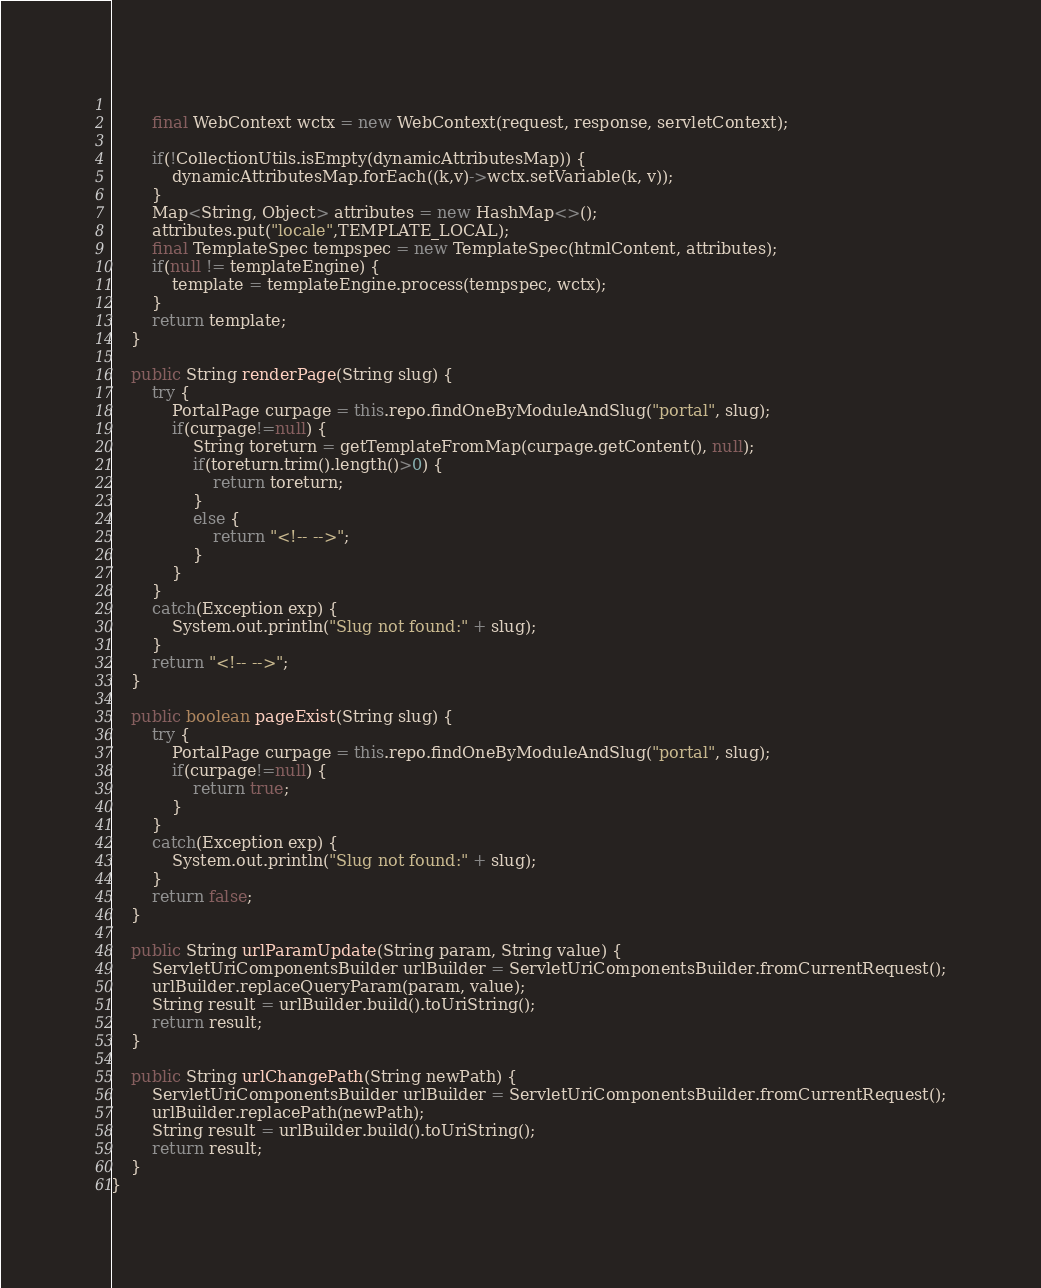<code> <loc_0><loc_0><loc_500><loc_500><_Java_>		
		final WebContext wctx = new WebContext(request, response, servletContext);
		
		if(!CollectionUtils.isEmpty(dynamicAttributesMap)) {
			dynamicAttributesMap.forEach((k,v)->wctx.setVariable(k, v));
		}
		Map<String, Object> attributes = new HashMap<>();
		attributes.put("locale",TEMPLATE_LOCAL);
		final TemplateSpec tempspec = new TemplateSpec(htmlContent, attributes);
		if(null != templateEngine) {
			template = templateEngine.process(tempspec, wctx);
		}
		return template;
	}
	
	public String renderPage(String slug) {		
		try {
			PortalPage curpage = this.repo.findOneByModuleAndSlug("portal", slug);
			if(curpage!=null) {
				String toreturn = getTemplateFromMap(curpage.getContent(), null);
				if(toreturn.trim().length()>0) {
					return toreturn;
				}
				else {					
					return "<!-- -->";
				}
			}
		}
		catch(Exception exp) {
			System.out.println("Slug not found:" + slug);
		}		
		return "<!-- -->";
	}
	
	public boolean pageExist(String slug) {
		try {
			PortalPage curpage = this.repo.findOneByModuleAndSlug("portal", slug);
			if(curpage!=null) {
				return true;
			}
		}
		catch(Exception exp) {
			System.out.println("Slug not found:" + slug);
		}
		return false;
	}
	
	public String urlParamUpdate(String param, String value) {		
		ServletUriComponentsBuilder urlBuilder = ServletUriComponentsBuilder.fromCurrentRequest();
		urlBuilder.replaceQueryParam(param, value);		
		String result = urlBuilder.build().toUriString();
		return result;
	}
	
	public String urlChangePath(String newPath) {
		ServletUriComponentsBuilder urlBuilder = ServletUriComponentsBuilder.fromCurrentRequest();
		urlBuilder.replacePath(newPath);		
		String result = urlBuilder.build().toUriString();
		return result;
	}
}
</code> 